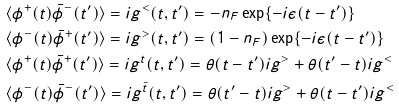Convert formula to latex. <formula><loc_0><loc_0><loc_500><loc_500>& \langle \phi ^ { + } ( t ) \bar { \phi } ^ { - } ( t ^ { \prime } ) \rangle = i g ^ { < } ( t , t ^ { \prime } ) = - n _ { F } \exp \{ - i \epsilon ( t - t ^ { \prime } ) \} \\ & \langle \phi ^ { - } ( t ) \bar { \phi } ^ { + } ( t ^ { \prime } ) \rangle = i g ^ { > } ( t , t ^ { \prime } ) = ( 1 - n _ { F } ) \exp \{ - i \epsilon ( t - t ^ { \prime } ) \} \\ & \langle \phi ^ { + } ( t ) \bar { \phi } ^ { + } ( t ^ { \prime } ) \rangle = i g ^ { t } ( t , t ^ { \prime } ) = \theta ( t - t ^ { \prime } ) i g ^ { > } + \theta ( t ^ { \prime } - t ) i g ^ { < } \\ & \langle \phi ^ { - } ( t ) \bar { \phi } ^ { - } ( t ^ { \prime } ) \rangle = i g ^ { \bar { t } } ( t , t ^ { \prime } ) = \theta ( t ^ { \prime } - t ) i g ^ { > } + \theta ( t - t ^ { \prime } ) i g ^ { < }</formula> 